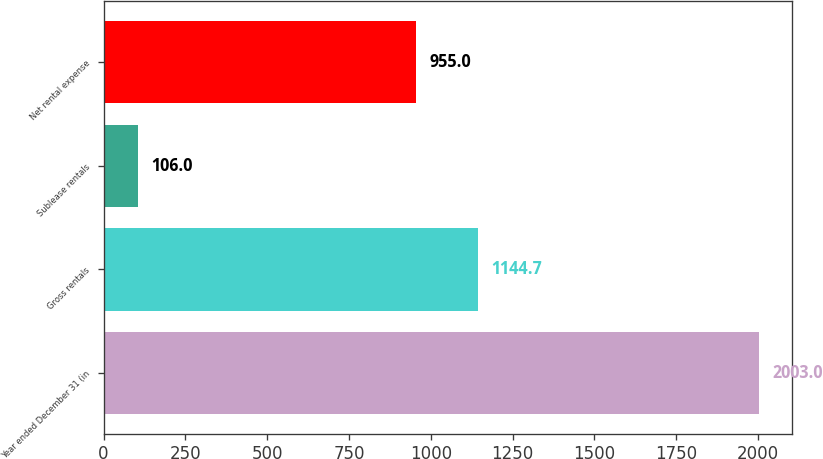Convert chart to OTSL. <chart><loc_0><loc_0><loc_500><loc_500><bar_chart><fcel>Year ended December 31 (in<fcel>Gross rentals<fcel>Sublease rentals<fcel>Net rental expense<nl><fcel>2003<fcel>1144.7<fcel>106<fcel>955<nl></chart> 